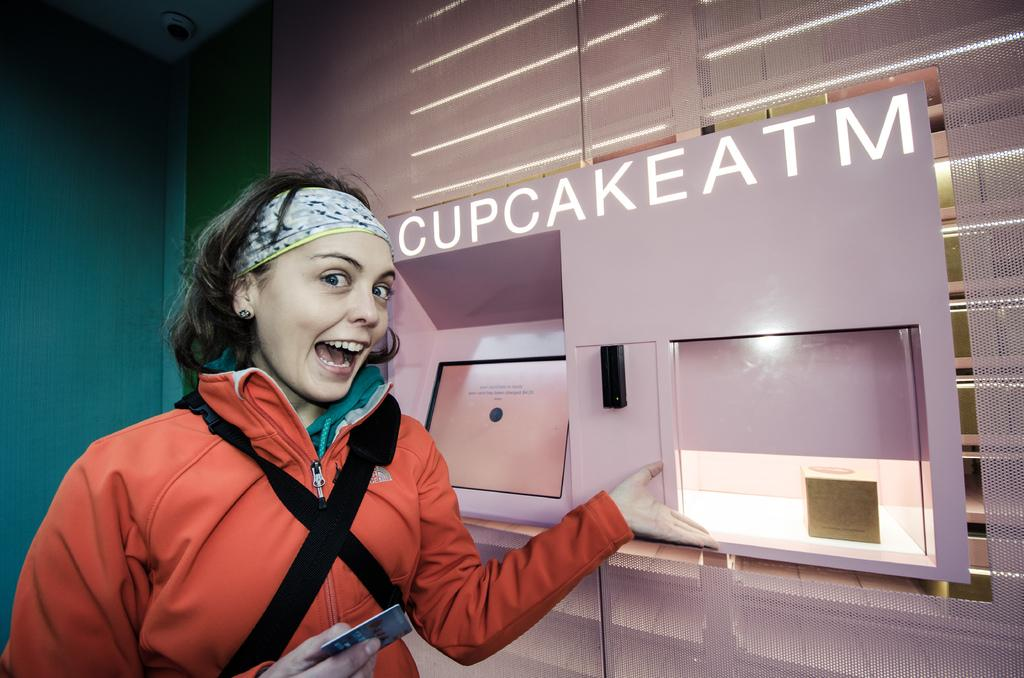<image>
Render a clear and concise summary of the photo. A girl showing a cupcake atm with her hand. 